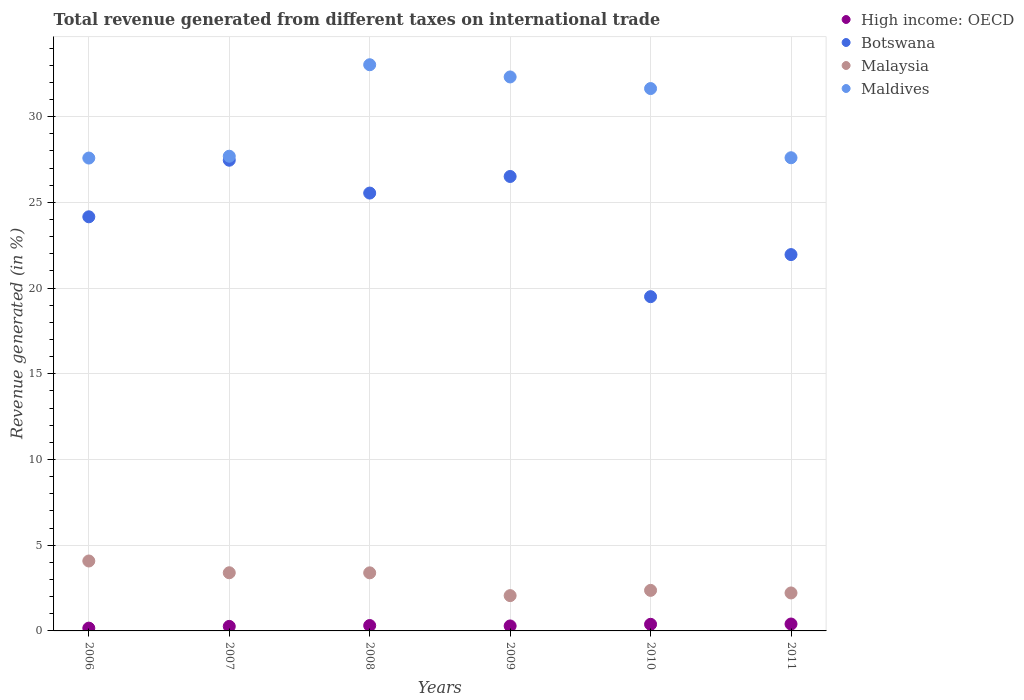How many different coloured dotlines are there?
Keep it short and to the point. 4. Is the number of dotlines equal to the number of legend labels?
Offer a very short reply. Yes. What is the total revenue generated in Malaysia in 2011?
Ensure brevity in your answer.  2.21. Across all years, what is the maximum total revenue generated in Maldives?
Provide a short and direct response. 33.03. Across all years, what is the minimum total revenue generated in Malaysia?
Provide a succinct answer. 2.06. In which year was the total revenue generated in High income: OECD maximum?
Give a very brief answer. 2011. In which year was the total revenue generated in Botswana minimum?
Your answer should be very brief. 2010. What is the total total revenue generated in Malaysia in the graph?
Your answer should be very brief. 17.5. What is the difference between the total revenue generated in Botswana in 2006 and that in 2011?
Provide a succinct answer. 2.2. What is the difference between the total revenue generated in Malaysia in 2007 and the total revenue generated in High income: OECD in 2008?
Provide a short and direct response. 3.08. What is the average total revenue generated in High income: OECD per year?
Your answer should be very brief. 0.3. In the year 2006, what is the difference between the total revenue generated in Maldives and total revenue generated in High income: OECD?
Ensure brevity in your answer.  27.42. In how many years, is the total revenue generated in Malaysia greater than 4 %?
Your answer should be very brief. 1. What is the ratio of the total revenue generated in Maldives in 2006 to that in 2007?
Your answer should be very brief. 1. Is the total revenue generated in Malaysia in 2007 less than that in 2011?
Offer a terse response. No. What is the difference between the highest and the second highest total revenue generated in High income: OECD?
Provide a short and direct response. 0.02. What is the difference between the highest and the lowest total revenue generated in Malaysia?
Make the answer very short. 2.02. In how many years, is the total revenue generated in Maldives greater than the average total revenue generated in Maldives taken over all years?
Offer a terse response. 3. Is the sum of the total revenue generated in High income: OECD in 2009 and 2010 greater than the maximum total revenue generated in Malaysia across all years?
Keep it short and to the point. No. Is it the case that in every year, the sum of the total revenue generated in Maldives and total revenue generated in Botswana  is greater than the sum of total revenue generated in High income: OECD and total revenue generated in Malaysia?
Make the answer very short. Yes. How many years are there in the graph?
Your answer should be very brief. 6. What is the difference between two consecutive major ticks on the Y-axis?
Provide a succinct answer. 5. Are the values on the major ticks of Y-axis written in scientific E-notation?
Keep it short and to the point. No. Does the graph contain grids?
Make the answer very short. Yes. How many legend labels are there?
Your response must be concise. 4. What is the title of the graph?
Offer a terse response. Total revenue generated from different taxes on international trade. Does "Estonia" appear as one of the legend labels in the graph?
Provide a short and direct response. No. What is the label or title of the X-axis?
Ensure brevity in your answer.  Years. What is the label or title of the Y-axis?
Offer a terse response. Revenue generated (in %). What is the Revenue generated (in %) in High income: OECD in 2006?
Your answer should be very brief. 0.16. What is the Revenue generated (in %) in Botswana in 2006?
Ensure brevity in your answer.  24.16. What is the Revenue generated (in %) of Malaysia in 2006?
Keep it short and to the point. 4.08. What is the Revenue generated (in %) in Maldives in 2006?
Your response must be concise. 27.59. What is the Revenue generated (in %) in High income: OECD in 2007?
Your response must be concise. 0.26. What is the Revenue generated (in %) in Botswana in 2007?
Keep it short and to the point. 27.46. What is the Revenue generated (in %) in Malaysia in 2007?
Provide a succinct answer. 3.39. What is the Revenue generated (in %) in Maldives in 2007?
Your response must be concise. 27.69. What is the Revenue generated (in %) in High income: OECD in 2008?
Offer a terse response. 0.31. What is the Revenue generated (in %) in Botswana in 2008?
Offer a very short reply. 25.54. What is the Revenue generated (in %) in Malaysia in 2008?
Make the answer very short. 3.39. What is the Revenue generated (in %) in Maldives in 2008?
Your answer should be compact. 33.03. What is the Revenue generated (in %) of High income: OECD in 2009?
Your answer should be compact. 0.29. What is the Revenue generated (in %) of Botswana in 2009?
Offer a very short reply. 26.51. What is the Revenue generated (in %) in Malaysia in 2009?
Keep it short and to the point. 2.06. What is the Revenue generated (in %) of Maldives in 2009?
Ensure brevity in your answer.  32.32. What is the Revenue generated (in %) in High income: OECD in 2010?
Make the answer very short. 0.39. What is the Revenue generated (in %) of Botswana in 2010?
Your response must be concise. 19.5. What is the Revenue generated (in %) in Malaysia in 2010?
Your answer should be very brief. 2.37. What is the Revenue generated (in %) of Maldives in 2010?
Make the answer very short. 31.64. What is the Revenue generated (in %) in High income: OECD in 2011?
Your answer should be very brief. 0.4. What is the Revenue generated (in %) in Botswana in 2011?
Keep it short and to the point. 21.95. What is the Revenue generated (in %) in Malaysia in 2011?
Give a very brief answer. 2.21. What is the Revenue generated (in %) in Maldives in 2011?
Make the answer very short. 27.6. Across all years, what is the maximum Revenue generated (in %) of High income: OECD?
Offer a very short reply. 0.4. Across all years, what is the maximum Revenue generated (in %) of Botswana?
Your answer should be very brief. 27.46. Across all years, what is the maximum Revenue generated (in %) in Malaysia?
Offer a very short reply. 4.08. Across all years, what is the maximum Revenue generated (in %) of Maldives?
Your response must be concise. 33.03. Across all years, what is the minimum Revenue generated (in %) in High income: OECD?
Offer a very short reply. 0.16. Across all years, what is the minimum Revenue generated (in %) in Botswana?
Provide a succinct answer. 19.5. Across all years, what is the minimum Revenue generated (in %) in Malaysia?
Offer a very short reply. 2.06. Across all years, what is the minimum Revenue generated (in %) of Maldives?
Your answer should be very brief. 27.59. What is the total Revenue generated (in %) of High income: OECD in the graph?
Offer a very short reply. 1.82. What is the total Revenue generated (in %) in Botswana in the graph?
Give a very brief answer. 145.12. What is the total Revenue generated (in %) in Malaysia in the graph?
Give a very brief answer. 17.5. What is the total Revenue generated (in %) in Maldives in the graph?
Offer a terse response. 179.87. What is the difference between the Revenue generated (in %) of High income: OECD in 2006 and that in 2007?
Provide a short and direct response. -0.1. What is the difference between the Revenue generated (in %) of Botswana in 2006 and that in 2007?
Give a very brief answer. -3.3. What is the difference between the Revenue generated (in %) of Malaysia in 2006 and that in 2007?
Give a very brief answer. 0.69. What is the difference between the Revenue generated (in %) of Maldives in 2006 and that in 2007?
Your response must be concise. -0.11. What is the difference between the Revenue generated (in %) in High income: OECD in 2006 and that in 2008?
Provide a succinct answer. -0.15. What is the difference between the Revenue generated (in %) in Botswana in 2006 and that in 2008?
Make the answer very short. -1.38. What is the difference between the Revenue generated (in %) in Malaysia in 2006 and that in 2008?
Offer a terse response. 0.69. What is the difference between the Revenue generated (in %) of Maldives in 2006 and that in 2008?
Offer a terse response. -5.44. What is the difference between the Revenue generated (in %) of High income: OECD in 2006 and that in 2009?
Provide a succinct answer. -0.13. What is the difference between the Revenue generated (in %) in Botswana in 2006 and that in 2009?
Offer a terse response. -2.35. What is the difference between the Revenue generated (in %) in Malaysia in 2006 and that in 2009?
Ensure brevity in your answer.  2.02. What is the difference between the Revenue generated (in %) in Maldives in 2006 and that in 2009?
Give a very brief answer. -4.73. What is the difference between the Revenue generated (in %) of High income: OECD in 2006 and that in 2010?
Keep it short and to the point. -0.22. What is the difference between the Revenue generated (in %) in Botswana in 2006 and that in 2010?
Provide a short and direct response. 4.66. What is the difference between the Revenue generated (in %) of Malaysia in 2006 and that in 2010?
Your answer should be compact. 1.71. What is the difference between the Revenue generated (in %) of Maldives in 2006 and that in 2010?
Give a very brief answer. -4.05. What is the difference between the Revenue generated (in %) of High income: OECD in 2006 and that in 2011?
Make the answer very short. -0.24. What is the difference between the Revenue generated (in %) in Botswana in 2006 and that in 2011?
Give a very brief answer. 2.2. What is the difference between the Revenue generated (in %) of Malaysia in 2006 and that in 2011?
Offer a terse response. 1.86. What is the difference between the Revenue generated (in %) in Maldives in 2006 and that in 2011?
Keep it short and to the point. -0.02. What is the difference between the Revenue generated (in %) of High income: OECD in 2007 and that in 2008?
Give a very brief answer. -0.05. What is the difference between the Revenue generated (in %) in Botswana in 2007 and that in 2008?
Provide a succinct answer. 1.92. What is the difference between the Revenue generated (in %) of Malaysia in 2007 and that in 2008?
Your answer should be very brief. 0.01. What is the difference between the Revenue generated (in %) of Maldives in 2007 and that in 2008?
Make the answer very short. -5.34. What is the difference between the Revenue generated (in %) of High income: OECD in 2007 and that in 2009?
Your answer should be very brief. -0.03. What is the difference between the Revenue generated (in %) of Botswana in 2007 and that in 2009?
Give a very brief answer. 0.95. What is the difference between the Revenue generated (in %) in Malaysia in 2007 and that in 2009?
Keep it short and to the point. 1.33. What is the difference between the Revenue generated (in %) in Maldives in 2007 and that in 2009?
Provide a succinct answer. -4.62. What is the difference between the Revenue generated (in %) of High income: OECD in 2007 and that in 2010?
Your answer should be compact. -0.12. What is the difference between the Revenue generated (in %) of Botswana in 2007 and that in 2010?
Keep it short and to the point. 7.96. What is the difference between the Revenue generated (in %) in Malaysia in 2007 and that in 2010?
Provide a short and direct response. 1.03. What is the difference between the Revenue generated (in %) of Maldives in 2007 and that in 2010?
Ensure brevity in your answer.  -3.95. What is the difference between the Revenue generated (in %) of High income: OECD in 2007 and that in 2011?
Keep it short and to the point. -0.14. What is the difference between the Revenue generated (in %) in Botswana in 2007 and that in 2011?
Provide a short and direct response. 5.51. What is the difference between the Revenue generated (in %) in Malaysia in 2007 and that in 2011?
Provide a short and direct response. 1.18. What is the difference between the Revenue generated (in %) of Maldives in 2007 and that in 2011?
Your answer should be compact. 0.09. What is the difference between the Revenue generated (in %) in High income: OECD in 2008 and that in 2009?
Offer a very short reply. 0.02. What is the difference between the Revenue generated (in %) of Botswana in 2008 and that in 2009?
Your answer should be compact. -0.97. What is the difference between the Revenue generated (in %) of Malaysia in 2008 and that in 2009?
Offer a very short reply. 1.33. What is the difference between the Revenue generated (in %) in Maldives in 2008 and that in 2009?
Offer a very short reply. 0.71. What is the difference between the Revenue generated (in %) of High income: OECD in 2008 and that in 2010?
Provide a short and direct response. -0.07. What is the difference between the Revenue generated (in %) in Botswana in 2008 and that in 2010?
Offer a terse response. 6.04. What is the difference between the Revenue generated (in %) in Malaysia in 2008 and that in 2010?
Keep it short and to the point. 1.02. What is the difference between the Revenue generated (in %) in Maldives in 2008 and that in 2010?
Your answer should be compact. 1.39. What is the difference between the Revenue generated (in %) of High income: OECD in 2008 and that in 2011?
Your answer should be very brief. -0.09. What is the difference between the Revenue generated (in %) in Botswana in 2008 and that in 2011?
Give a very brief answer. 3.59. What is the difference between the Revenue generated (in %) in Malaysia in 2008 and that in 2011?
Give a very brief answer. 1.17. What is the difference between the Revenue generated (in %) in Maldives in 2008 and that in 2011?
Provide a succinct answer. 5.42. What is the difference between the Revenue generated (in %) in High income: OECD in 2009 and that in 2010?
Offer a terse response. -0.1. What is the difference between the Revenue generated (in %) of Botswana in 2009 and that in 2010?
Give a very brief answer. 7.01. What is the difference between the Revenue generated (in %) of Malaysia in 2009 and that in 2010?
Make the answer very short. -0.31. What is the difference between the Revenue generated (in %) in Maldives in 2009 and that in 2010?
Your answer should be very brief. 0.68. What is the difference between the Revenue generated (in %) of High income: OECD in 2009 and that in 2011?
Give a very brief answer. -0.11. What is the difference between the Revenue generated (in %) in Botswana in 2009 and that in 2011?
Provide a short and direct response. 4.56. What is the difference between the Revenue generated (in %) of Malaysia in 2009 and that in 2011?
Keep it short and to the point. -0.16. What is the difference between the Revenue generated (in %) of Maldives in 2009 and that in 2011?
Ensure brevity in your answer.  4.71. What is the difference between the Revenue generated (in %) of High income: OECD in 2010 and that in 2011?
Give a very brief answer. -0.02. What is the difference between the Revenue generated (in %) of Botswana in 2010 and that in 2011?
Give a very brief answer. -2.45. What is the difference between the Revenue generated (in %) of Malaysia in 2010 and that in 2011?
Your response must be concise. 0.15. What is the difference between the Revenue generated (in %) of Maldives in 2010 and that in 2011?
Give a very brief answer. 4.04. What is the difference between the Revenue generated (in %) in High income: OECD in 2006 and the Revenue generated (in %) in Botswana in 2007?
Offer a very short reply. -27.3. What is the difference between the Revenue generated (in %) of High income: OECD in 2006 and the Revenue generated (in %) of Malaysia in 2007?
Offer a very short reply. -3.23. What is the difference between the Revenue generated (in %) in High income: OECD in 2006 and the Revenue generated (in %) in Maldives in 2007?
Keep it short and to the point. -27.53. What is the difference between the Revenue generated (in %) in Botswana in 2006 and the Revenue generated (in %) in Malaysia in 2007?
Ensure brevity in your answer.  20.77. What is the difference between the Revenue generated (in %) of Botswana in 2006 and the Revenue generated (in %) of Maldives in 2007?
Offer a very short reply. -3.53. What is the difference between the Revenue generated (in %) of Malaysia in 2006 and the Revenue generated (in %) of Maldives in 2007?
Keep it short and to the point. -23.61. What is the difference between the Revenue generated (in %) of High income: OECD in 2006 and the Revenue generated (in %) of Botswana in 2008?
Keep it short and to the point. -25.38. What is the difference between the Revenue generated (in %) of High income: OECD in 2006 and the Revenue generated (in %) of Malaysia in 2008?
Your answer should be very brief. -3.23. What is the difference between the Revenue generated (in %) in High income: OECD in 2006 and the Revenue generated (in %) in Maldives in 2008?
Keep it short and to the point. -32.87. What is the difference between the Revenue generated (in %) of Botswana in 2006 and the Revenue generated (in %) of Malaysia in 2008?
Your answer should be very brief. 20.77. What is the difference between the Revenue generated (in %) of Botswana in 2006 and the Revenue generated (in %) of Maldives in 2008?
Your response must be concise. -8.87. What is the difference between the Revenue generated (in %) in Malaysia in 2006 and the Revenue generated (in %) in Maldives in 2008?
Offer a very short reply. -28.95. What is the difference between the Revenue generated (in %) of High income: OECD in 2006 and the Revenue generated (in %) of Botswana in 2009?
Ensure brevity in your answer.  -26.35. What is the difference between the Revenue generated (in %) of High income: OECD in 2006 and the Revenue generated (in %) of Malaysia in 2009?
Ensure brevity in your answer.  -1.9. What is the difference between the Revenue generated (in %) in High income: OECD in 2006 and the Revenue generated (in %) in Maldives in 2009?
Offer a terse response. -32.15. What is the difference between the Revenue generated (in %) in Botswana in 2006 and the Revenue generated (in %) in Malaysia in 2009?
Keep it short and to the point. 22.1. What is the difference between the Revenue generated (in %) of Botswana in 2006 and the Revenue generated (in %) of Maldives in 2009?
Keep it short and to the point. -8.16. What is the difference between the Revenue generated (in %) of Malaysia in 2006 and the Revenue generated (in %) of Maldives in 2009?
Keep it short and to the point. -28.24. What is the difference between the Revenue generated (in %) of High income: OECD in 2006 and the Revenue generated (in %) of Botswana in 2010?
Give a very brief answer. -19.34. What is the difference between the Revenue generated (in %) of High income: OECD in 2006 and the Revenue generated (in %) of Malaysia in 2010?
Your answer should be very brief. -2.2. What is the difference between the Revenue generated (in %) in High income: OECD in 2006 and the Revenue generated (in %) in Maldives in 2010?
Your answer should be compact. -31.48. What is the difference between the Revenue generated (in %) in Botswana in 2006 and the Revenue generated (in %) in Malaysia in 2010?
Provide a short and direct response. 21.79. What is the difference between the Revenue generated (in %) in Botswana in 2006 and the Revenue generated (in %) in Maldives in 2010?
Your answer should be very brief. -7.48. What is the difference between the Revenue generated (in %) in Malaysia in 2006 and the Revenue generated (in %) in Maldives in 2010?
Offer a very short reply. -27.56. What is the difference between the Revenue generated (in %) of High income: OECD in 2006 and the Revenue generated (in %) of Botswana in 2011?
Your answer should be very brief. -21.79. What is the difference between the Revenue generated (in %) of High income: OECD in 2006 and the Revenue generated (in %) of Malaysia in 2011?
Ensure brevity in your answer.  -2.05. What is the difference between the Revenue generated (in %) in High income: OECD in 2006 and the Revenue generated (in %) in Maldives in 2011?
Provide a succinct answer. -27.44. What is the difference between the Revenue generated (in %) of Botswana in 2006 and the Revenue generated (in %) of Malaysia in 2011?
Your response must be concise. 21.94. What is the difference between the Revenue generated (in %) in Botswana in 2006 and the Revenue generated (in %) in Maldives in 2011?
Give a very brief answer. -3.45. What is the difference between the Revenue generated (in %) in Malaysia in 2006 and the Revenue generated (in %) in Maldives in 2011?
Your answer should be compact. -23.52. What is the difference between the Revenue generated (in %) of High income: OECD in 2007 and the Revenue generated (in %) of Botswana in 2008?
Offer a very short reply. -25.28. What is the difference between the Revenue generated (in %) of High income: OECD in 2007 and the Revenue generated (in %) of Malaysia in 2008?
Offer a very short reply. -3.12. What is the difference between the Revenue generated (in %) of High income: OECD in 2007 and the Revenue generated (in %) of Maldives in 2008?
Give a very brief answer. -32.76. What is the difference between the Revenue generated (in %) in Botswana in 2007 and the Revenue generated (in %) in Malaysia in 2008?
Keep it short and to the point. 24.07. What is the difference between the Revenue generated (in %) of Botswana in 2007 and the Revenue generated (in %) of Maldives in 2008?
Offer a terse response. -5.57. What is the difference between the Revenue generated (in %) of Malaysia in 2007 and the Revenue generated (in %) of Maldives in 2008?
Keep it short and to the point. -29.64. What is the difference between the Revenue generated (in %) of High income: OECD in 2007 and the Revenue generated (in %) of Botswana in 2009?
Ensure brevity in your answer.  -26.25. What is the difference between the Revenue generated (in %) of High income: OECD in 2007 and the Revenue generated (in %) of Malaysia in 2009?
Provide a succinct answer. -1.79. What is the difference between the Revenue generated (in %) in High income: OECD in 2007 and the Revenue generated (in %) in Maldives in 2009?
Keep it short and to the point. -32.05. What is the difference between the Revenue generated (in %) of Botswana in 2007 and the Revenue generated (in %) of Malaysia in 2009?
Keep it short and to the point. 25.4. What is the difference between the Revenue generated (in %) of Botswana in 2007 and the Revenue generated (in %) of Maldives in 2009?
Make the answer very short. -4.86. What is the difference between the Revenue generated (in %) in Malaysia in 2007 and the Revenue generated (in %) in Maldives in 2009?
Give a very brief answer. -28.92. What is the difference between the Revenue generated (in %) of High income: OECD in 2007 and the Revenue generated (in %) of Botswana in 2010?
Ensure brevity in your answer.  -19.24. What is the difference between the Revenue generated (in %) in High income: OECD in 2007 and the Revenue generated (in %) in Malaysia in 2010?
Provide a succinct answer. -2.1. What is the difference between the Revenue generated (in %) of High income: OECD in 2007 and the Revenue generated (in %) of Maldives in 2010?
Offer a terse response. -31.38. What is the difference between the Revenue generated (in %) in Botswana in 2007 and the Revenue generated (in %) in Malaysia in 2010?
Ensure brevity in your answer.  25.09. What is the difference between the Revenue generated (in %) of Botswana in 2007 and the Revenue generated (in %) of Maldives in 2010?
Make the answer very short. -4.18. What is the difference between the Revenue generated (in %) in Malaysia in 2007 and the Revenue generated (in %) in Maldives in 2010?
Offer a terse response. -28.25. What is the difference between the Revenue generated (in %) of High income: OECD in 2007 and the Revenue generated (in %) of Botswana in 2011?
Keep it short and to the point. -21.69. What is the difference between the Revenue generated (in %) of High income: OECD in 2007 and the Revenue generated (in %) of Malaysia in 2011?
Provide a succinct answer. -1.95. What is the difference between the Revenue generated (in %) of High income: OECD in 2007 and the Revenue generated (in %) of Maldives in 2011?
Your response must be concise. -27.34. What is the difference between the Revenue generated (in %) of Botswana in 2007 and the Revenue generated (in %) of Malaysia in 2011?
Keep it short and to the point. 25.24. What is the difference between the Revenue generated (in %) in Botswana in 2007 and the Revenue generated (in %) in Maldives in 2011?
Your response must be concise. -0.14. What is the difference between the Revenue generated (in %) in Malaysia in 2007 and the Revenue generated (in %) in Maldives in 2011?
Your answer should be very brief. -24.21. What is the difference between the Revenue generated (in %) of High income: OECD in 2008 and the Revenue generated (in %) of Botswana in 2009?
Provide a short and direct response. -26.2. What is the difference between the Revenue generated (in %) in High income: OECD in 2008 and the Revenue generated (in %) in Malaysia in 2009?
Your response must be concise. -1.75. What is the difference between the Revenue generated (in %) of High income: OECD in 2008 and the Revenue generated (in %) of Maldives in 2009?
Your answer should be very brief. -32. What is the difference between the Revenue generated (in %) of Botswana in 2008 and the Revenue generated (in %) of Malaysia in 2009?
Provide a succinct answer. 23.48. What is the difference between the Revenue generated (in %) in Botswana in 2008 and the Revenue generated (in %) in Maldives in 2009?
Offer a terse response. -6.77. What is the difference between the Revenue generated (in %) of Malaysia in 2008 and the Revenue generated (in %) of Maldives in 2009?
Your response must be concise. -28.93. What is the difference between the Revenue generated (in %) in High income: OECD in 2008 and the Revenue generated (in %) in Botswana in 2010?
Offer a very short reply. -19.19. What is the difference between the Revenue generated (in %) in High income: OECD in 2008 and the Revenue generated (in %) in Malaysia in 2010?
Your answer should be compact. -2.05. What is the difference between the Revenue generated (in %) of High income: OECD in 2008 and the Revenue generated (in %) of Maldives in 2010?
Your answer should be compact. -31.33. What is the difference between the Revenue generated (in %) in Botswana in 2008 and the Revenue generated (in %) in Malaysia in 2010?
Provide a succinct answer. 23.18. What is the difference between the Revenue generated (in %) of Botswana in 2008 and the Revenue generated (in %) of Maldives in 2010?
Provide a succinct answer. -6.1. What is the difference between the Revenue generated (in %) in Malaysia in 2008 and the Revenue generated (in %) in Maldives in 2010?
Provide a succinct answer. -28.25. What is the difference between the Revenue generated (in %) in High income: OECD in 2008 and the Revenue generated (in %) in Botswana in 2011?
Your answer should be very brief. -21.64. What is the difference between the Revenue generated (in %) of High income: OECD in 2008 and the Revenue generated (in %) of Malaysia in 2011?
Your answer should be very brief. -1.9. What is the difference between the Revenue generated (in %) of High income: OECD in 2008 and the Revenue generated (in %) of Maldives in 2011?
Your answer should be very brief. -27.29. What is the difference between the Revenue generated (in %) of Botswana in 2008 and the Revenue generated (in %) of Malaysia in 2011?
Provide a short and direct response. 23.33. What is the difference between the Revenue generated (in %) of Botswana in 2008 and the Revenue generated (in %) of Maldives in 2011?
Your answer should be very brief. -2.06. What is the difference between the Revenue generated (in %) of Malaysia in 2008 and the Revenue generated (in %) of Maldives in 2011?
Provide a short and direct response. -24.22. What is the difference between the Revenue generated (in %) of High income: OECD in 2009 and the Revenue generated (in %) of Botswana in 2010?
Ensure brevity in your answer.  -19.21. What is the difference between the Revenue generated (in %) in High income: OECD in 2009 and the Revenue generated (in %) in Malaysia in 2010?
Keep it short and to the point. -2.08. What is the difference between the Revenue generated (in %) in High income: OECD in 2009 and the Revenue generated (in %) in Maldives in 2010?
Your response must be concise. -31.35. What is the difference between the Revenue generated (in %) in Botswana in 2009 and the Revenue generated (in %) in Malaysia in 2010?
Your answer should be compact. 24.14. What is the difference between the Revenue generated (in %) of Botswana in 2009 and the Revenue generated (in %) of Maldives in 2010?
Give a very brief answer. -5.13. What is the difference between the Revenue generated (in %) of Malaysia in 2009 and the Revenue generated (in %) of Maldives in 2010?
Your response must be concise. -29.58. What is the difference between the Revenue generated (in %) of High income: OECD in 2009 and the Revenue generated (in %) of Botswana in 2011?
Your answer should be compact. -21.66. What is the difference between the Revenue generated (in %) of High income: OECD in 2009 and the Revenue generated (in %) of Malaysia in 2011?
Keep it short and to the point. -1.92. What is the difference between the Revenue generated (in %) in High income: OECD in 2009 and the Revenue generated (in %) in Maldives in 2011?
Give a very brief answer. -27.31. What is the difference between the Revenue generated (in %) in Botswana in 2009 and the Revenue generated (in %) in Malaysia in 2011?
Offer a terse response. 24.3. What is the difference between the Revenue generated (in %) of Botswana in 2009 and the Revenue generated (in %) of Maldives in 2011?
Offer a very short reply. -1.09. What is the difference between the Revenue generated (in %) in Malaysia in 2009 and the Revenue generated (in %) in Maldives in 2011?
Provide a succinct answer. -25.54. What is the difference between the Revenue generated (in %) in High income: OECD in 2010 and the Revenue generated (in %) in Botswana in 2011?
Make the answer very short. -21.57. What is the difference between the Revenue generated (in %) in High income: OECD in 2010 and the Revenue generated (in %) in Malaysia in 2011?
Your answer should be very brief. -1.83. What is the difference between the Revenue generated (in %) of High income: OECD in 2010 and the Revenue generated (in %) of Maldives in 2011?
Give a very brief answer. -27.22. What is the difference between the Revenue generated (in %) of Botswana in 2010 and the Revenue generated (in %) of Malaysia in 2011?
Offer a terse response. 17.28. What is the difference between the Revenue generated (in %) of Botswana in 2010 and the Revenue generated (in %) of Maldives in 2011?
Provide a short and direct response. -8.1. What is the difference between the Revenue generated (in %) of Malaysia in 2010 and the Revenue generated (in %) of Maldives in 2011?
Make the answer very short. -25.24. What is the average Revenue generated (in %) in High income: OECD per year?
Ensure brevity in your answer.  0.3. What is the average Revenue generated (in %) in Botswana per year?
Your response must be concise. 24.19. What is the average Revenue generated (in %) of Malaysia per year?
Ensure brevity in your answer.  2.92. What is the average Revenue generated (in %) of Maldives per year?
Provide a short and direct response. 29.98. In the year 2006, what is the difference between the Revenue generated (in %) of High income: OECD and Revenue generated (in %) of Botswana?
Keep it short and to the point. -24. In the year 2006, what is the difference between the Revenue generated (in %) in High income: OECD and Revenue generated (in %) in Malaysia?
Offer a terse response. -3.92. In the year 2006, what is the difference between the Revenue generated (in %) of High income: OECD and Revenue generated (in %) of Maldives?
Give a very brief answer. -27.42. In the year 2006, what is the difference between the Revenue generated (in %) of Botswana and Revenue generated (in %) of Malaysia?
Provide a short and direct response. 20.08. In the year 2006, what is the difference between the Revenue generated (in %) of Botswana and Revenue generated (in %) of Maldives?
Keep it short and to the point. -3.43. In the year 2006, what is the difference between the Revenue generated (in %) of Malaysia and Revenue generated (in %) of Maldives?
Keep it short and to the point. -23.51. In the year 2007, what is the difference between the Revenue generated (in %) in High income: OECD and Revenue generated (in %) in Botswana?
Provide a succinct answer. -27.19. In the year 2007, what is the difference between the Revenue generated (in %) in High income: OECD and Revenue generated (in %) in Malaysia?
Offer a very short reply. -3.13. In the year 2007, what is the difference between the Revenue generated (in %) of High income: OECD and Revenue generated (in %) of Maldives?
Keep it short and to the point. -27.43. In the year 2007, what is the difference between the Revenue generated (in %) in Botswana and Revenue generated (in %) in Malaysia?
Keep it short and to the point. 24.07. In the year 2007, what is the difference between the Revenue generated (in %) in Botswana and Revenue generated (in %) in Maldives?
Keep it short and to the point. -0.23. In the year 2007, what is the difference between the Revenue generated (in %) in Malaysia and Revenue generated (in %) in Maldives?
Your answer should be very brief. -24.3. In the year 2008, what is the difference between the Revenue generated (in %) of High income: OECD and Revenue generated (in %) of Botswana?
Provide a short and direct response. -25.23. In the year 2008, what is the difference between the Revenue generated (in %) of High income: OECD and Revenue generated (in %) of Malaysia?
Offer a very short reply. -3.07. In the year 2008, what is the difference between the Revenue generated (in %) of High income: OECD and Revenue generated (in %) of Maldives?
Keep it short and to the point. -32.71. In the year 2008, what is the difference between the Revenue generated (in %) of Botswana and Revenue generated (in %) of Malaysia?
Offer a terse response. 22.15. In the year 2008, what is the difference between the Revenue generated (in %) of Botswana and Revenue generated (in %) of Maldives?
Your answer should be very brief. -7.49. In the year 2008, what is the difference between the Revenue generated (in %) of Malaysia and Revenue generated (in %) of Maldives?
Make the answer very short. -29.64. In the year 2009, what is the difference between the Revenue generated (in %) of High income: OECD and Revenue generated (in %) of Botswana?
Make the answer very short. -26.22. In the year 2009, what is the difference between the Revenue generated (in %) in High income: OECD and Revenue generated (in %) in Malaysia?
Your answer should be compact. -1.77. In the year 2009, what is the difference between the Revenue generated (in %) of High income: OECD and Revenue generated (in %) of Maldives?
Keep it short and to the point. -32.03. In the year 2009, what is the difference between the Revenue generated (in %) of Botswana and Revenue generated (in %) of Malaysia?
Your response must be concise. 24.45. In the year 2009, what is the difference between the Revenue generated (in %) in Botswana and Revenue generated (in %) in Maldives?
Offer a very short reply. -5.81. In the year 2009, what is the difference between the Revenue generated (in %) in Malaysia and Revenue generated (in %) in Maldives?
Your response must be concise. -30.26. In the year 2010, what is the difference between the Revenue generated (in %) in High income: OECD and Revenue generated (in %) in Botswana?
Offer a very short reply. -19.11. In the year 2010, what is the difference between the Revenue generated (in %) of High income: OECD and Revenue generated (in %) of Malaysia?
Provide a succinct answer. -1.98. In the year 2010, what is the difference between the Revenue generated (in %) of High income: OECD and Revenue generated (in %) of Maldives?
Offer a very short reply. -31.25. In the year 2010, what is the difference between the Revenue generated (in %) in Botswana and Revenue generated (in %) in Malaysia?
Your answer should be compact. 17.13. In the year 2010, what is the difference between the Revenue generated (in %) in Botswana and Revenue generated (in %) in Maldives?
Make the answer very short. -12.14. In the year 2010, what is the difference between the Revenue generated (in %) in Malaysia and Revenue generated (in %) in Maldives?
Offer a very short reply. -29.27. In the year 2011, what is the difference between the Revenue generated (in %) of High income: OECD and Revenue generated (in %) of Botswana?
Ensure brevity in your answer.  -21.55. In the year 2011, what is the difference between the Revenue generated (in %) of High income: OECD and Revenue generated (in %) of Malaysia?
Your answer should be very brief. -1.81. In the year 2011, what is the difference between the Revenue generated (in %) of High income: OECD and Revenue generated (in %) of Maldives?
Provide a short and direct response. -27.2. In the year 2011, what is the difference between the Revenue generated (in %) in Botswana and Revenue generated (in %) in Malaysia?
Ensure brevity in your answer.  19.74. In the year 2011, what is the difference between the Revenue generated (in %) of Botswana and Revenue generated (in %) of Maldives?
Your response must be concise. -5.65. In the year 2011, what is the difference between the Revenue generated (in %) of Malaysia and Revenue generated (in %) of Maldives?
Give a very brief answer. -25.39. What is the ratio of the Revenue generated (in %) in High income: OECD in 2006 to that in 2007?
Provide a succinct answer. 0.62. What is the ratio of the Revenue generated (in %) in Botswana in 2006 to that in 2007?
Offer a terse response. 0.88. What is the ratio of the Revenue generated (in %) in Malaysia in 2006 to that in 2007?
Provide a short and direct response. 1.2. What is the ratio of the Revenue generated (in %) in Maldives in 2006 to that in 2007?
Keep it short and to the point. 1. What is the ratio of the Revenue generated (in %) of High income: OECD in 2006 to that in 2008?
Your response must be concise. 0.52. What is the ratio of the Revenue generated (in %) of Botswana in 2006 to that in 2008?
Your answer should be compact. 0.95. What is the ratio of the Revenue generated (in %) of Malaysia in 2006 to that in 2008?
Give a very brief answer. 1.2. What is the ratio of the Revenue generated (in %) of Maldives in 2006 to that in 2008?
Provide a short and direct response. 0.84. What is the ratio of the Revenue generated (in %) in High income: OECD in 2006 to that in 2009?
Your answer should be compact. 0.56. What is the ratio of the Revenue generated (in %) of Botswana in 2006 to that in 2009?
Your answer should be compact. 0.91. What is the ratio of the Revenue generated (in %) in Malaysia in 2006 to that in 2009?
Provide a short and direct response. 1.98. What is the ratio of the Revenue generated (in %) of Maldives in 2006 to that in 2009?
Your answer should be very brief. 0.85. What is the ratio of the Revenue generated (in %) in High income: OECD in 2006 to that in 2010?
Keep it short and to the point. 0.42. What is the ratio of the Revenue generated (in %) of Botswana in 2006 to that in 2010?
Ensure brevity in your answer.  1.24. What is the ratio of the Revenue generated (in %) in Malaysia in 2006 to that in 2010?
Your response must be concise. 1.72. What is the ratio of the Revenue generated (in %) of Maldives in 2006 to that in 2010?
Your answer should be compact. 0.87. What is the ratio of the Revenue generated (in %) in High income: OECD in 2006 to that in 2011?
Keep it short and to the point. 0.4. What is the ratio of the Revenue generated (in %) in Botswana in 2006 to that in 2011?
Keep it short and to the point. 1.1. What is the ratio of the Revenue generated (in %) in Malaysia in 2006 to that in 2011?
Make the answer very short. 1.84. What is the ratio of the Revenue generated (in %) of High income: OECD in 2007 to that in 2008?
Provide a short and direct response. 0.84. What is the ratio of the Revenue generated (in %) in Botswana in 2007 to that in 2008?
Keep it short and to the point. 1.07. What is the ratio of the Revenue generated (in %) in Malaysia in 2007 to that in 2008?
Offer a very short reply. 1. What is the ratio of the Revenue generated (in %) of Maldives in 2007 to that in 2008?
Provide a short and direct response. 0.84. What is the ratio of the Revenue generated (in %) in High income: OECD in 2007 to that in 2009?
Ensure brevity in your answer.  0.91. What is the ratio of the Revenue generated (in %) in Botswana in 2007 to that in 2009?
Give a very brief answer. 1.04. What is the ratio of the Revenue generated (in %) in Malaysia in 2007 to that in 2009?
Provide a succinct answer. 1.65. What is the ratio of the Revenue generated (in %) of Maldives in 2007 to that in 2009?
Offer a terse response. 0.86. What is the ratio of the Revenue generated (in %) in High income: OECD in 2007 to that in 2010?
Offer a terse response. 0.68. What is the ratio of the Revenue generated (in %) of Botswana in 2007 to that in 2010?
Provide a short and direct response. 1.41. What is the ratio of the Revenue generated (in %) of Malaysia in 2007 to that in 2010?
Your answer should be compact. 1.43. What is the ratio of the Revenue generated (in %) in Maldives in 2007 to that in 2010?
Ensure brevity in your answer.  0.88. What is the ratio of the Revenue generated (in %) of High income: OECD in 2007 to that in 2011?
Provide a short and direct response. 0.66. What is the ratio of the Revenue generated (in %) of Botswana in 2007 to that in 2011?
Make the answer very short. 1.25. What is the ratio of the Revenue generated (in %) in Malaysia in 2007 to that in 2011?
Offer a very short reply. 1.53. What is the ratio of the Revenue generated (in %) in High income: OECD in 2008 to that in 2009?
Offer a very short reply. 1.08. What is the ratio of the Revenue generated (in %) in Botswana in 2008 to that in 2009?
Keep it short and to the point. 0.96. What is the ratio of the Revenue generated (in %) of Malaysia in 2008 to that in 2009?
Offer a very short reply. 1.65. What is the ratio of the Revenue generated (in %) in High income: OECD in 2008 to that in 2010?
Provide a short and direct response. 0.81. What is the ratio of the Revenue generated (in %) in Botswana in 2008 to that in 2010?
Your response must be concise. 1.31. What is the ratio of the Revenue generated (in %) in Malaysia in 2008 to that in 2010?
Your response must be concise. 1.43. What is the ratio of the Revenue generated (in %) of Maldives in 2008 to that in 2010?
Offer a very short reply. 1.04. What is the ratio of the Revenue generated (in %) in High income: OECD in 2008 to that in 2011?
Give a very brief answer. 0.78. What is the ratio of the Revenue generated (in %) in Botswana in 2008 to that in 2011?
Ensure brevity in your answer.  1.16. What is the ratio of the Revenue generated (in %) of Malaysia in 2008 to that in 2011?
Give a very brief answer. 1.53. What is the ratio of the Revenue generated (in %) of Maldives in 2008 to that in 2011?
Provide a short and direct response. 1.2. What is the ratio of the Revenue generated (in %) in High income: OECD in 2009 to that in 2010?
Your response must be concise. 0.75. What is the ratio of the Revenue generated (in %) in Botswana in 2009 to that in 2010?
Your answer should be very brief. 1.36. What is the ratio of the Revenue generated (in %) in Malaysia in 2009 to that in 2010?
Offer a terse response. 0.87. What is the ratio of the Revenue generated (in %) of Maldives in 2009 to that in 2010?
Provide a short and direct response. 1.02. What is the ratio of the Revenue generated (in %) in High income: OECD in 2009 to that in 2011?
Give a very brief answer. 0.72. What is the ratio of the Revenue generated (in %) of Botswana in 2009 to that in 2011?
Provide a short and direct response. 1.21. What is the ratio of the Revenue generated (in %) of Malaysia in 2009 to that in 2011?
Give a very brief answer. 0.93. What is the ratio of the Revenue generated (in %) in Maldives in 2009 to that in 2011?
Offer a very short reply. 1.17. What is the ratio of the Revenue generated (in %) of High income: OECD in 2010 to that in 2011?
Your answer should be compact. 0.96. What is the ratio of the Revenue generated (in %) of Botswana in 2010 to that in 2011?
Your answer should be very brief. 0.89. What is the ratio of the Revenue generated (in %) in Malaysia in 2010 to that in 2011?
Your answer should be compact. 1.07. What is the ratio of the Revenue generated (in %) in Maldives in 2010 to that in 2011?
Give a very brief answer. 1.15. What is the difference between the highest and the second highest Revenue generated (in %) of High income: OECD?
Give a very brief answer. 0.02. What is the difference between the highest and the second highest Revenue generated (in %) in Botswana?
Make the answer very short. 0.95. What is the difference between the highest and the second highest Revenue generated (in %) in Malaysia?
Give a very brief answer. 0.69. What is the difference between the highest and the second highest Revenue generated (in %) of Maldives?
Ensure brevity in your answer.  0.71. What is the difference between the highest and the lowest Revenue generated (in %) of High income: OECD?
Offer a very short reply. 0.24. What is the difference between the highest and the lowest Revenue generated (in %) in Botswana?
Your answer should be very brief. 7.96. What is the difference between the highest and the lowest Revenue generated (in %) in Malaysia?
Your response must be concise. 2.02. What is the difference between the highest and the lowest Revenue generated (in %) of Maldives?
Ensure brevity in your answer.  5.44. 